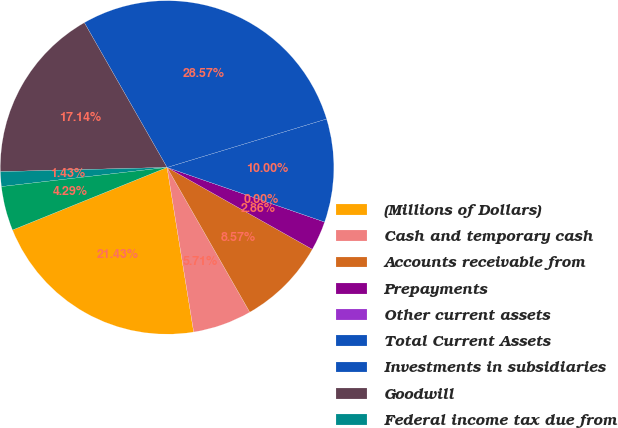Convert chart. <chart><loc_0><loc_0><loc_500><loc_500><pie_chart><fcel>(Millions of Dollars)<fcel>Cash and temporary cash<fcel>Accounts receivable from<fcel>Prepayments<fcel>Other current assets<fcel>Total Current Assets<fcel>Investments in subsidiaries<fcel>Goodwill<fcel>Federal income tax due from<fcel>Deferred income tax<nl><fcel>21.43%<fcel>5.71%<fcel>8.57%<fcel>2.86%<fcel>0.0%<fcel>10.0%<fcel>28.57%<fcel>17.14%<fcel>1.43%<fcel>4.29%<nl></chart> 